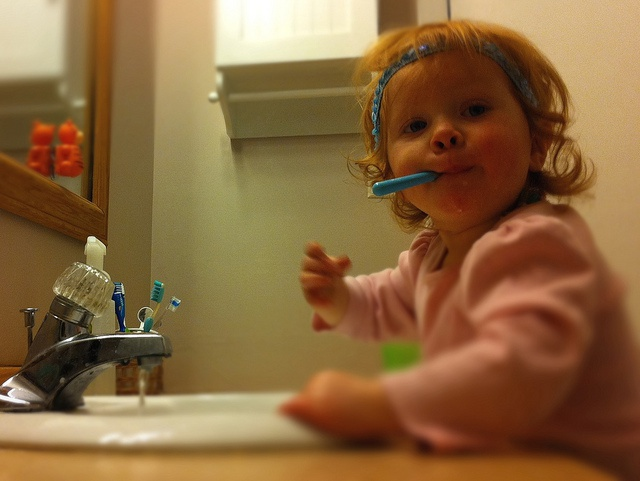Describe the objects in this image and their specific colors. I can see people in beige, maroon, brown, salmon, and black tones, sink in beige and tan tones, teddy bear in beige, brown, red, and maroon tones, bottle in beige, olive, and khaki tones, and toothbrush in beige, black, teal, and darkblue tones in this image. 